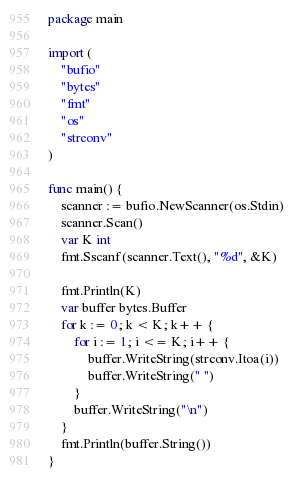<code> <loc_0><loc_0><loc_500><loc_500><_Go_>package main

import (
	"bufio"
	"bytes"
	"fmt"
	"os"
	"strconv"
)

func main() {
	scanner := bufio.NewScanner(os.Stdin)
	scanner.Scan()
	var K int
	fmt.Sscanf(scanner.Text(), "%d", &K)

	fmt.Println(K)
	var buffer bytes.Buffer
	for k := 0; k < K; k++ {
		for i := 1; i <= K; i++ {
			buffer.WriteString(strconv.Itoa(i))
			buffer.WriteString(" ")
		}
		buffer.WriteString("\n")
	}
	fmt.Println(buffer.String())
}
</code> 